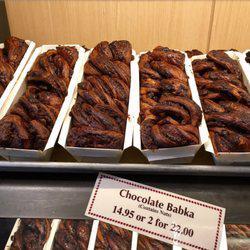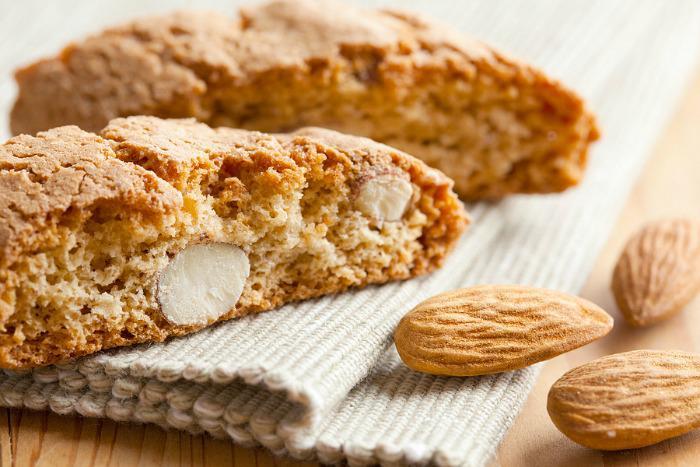The first image is the image on the left, the second image is the image on the right. Examine the images to the left and right. Is the description "Loaves of bakery items are sitting in white rectangular containers in the image on the left." accurate? Answer yes or no. Yes. The first image is the image on the left, the second image is the image on the right. Analyze the images presented: Is the assertion "An image shows multiple baked treats of the same type, packaged in open-top white rectangular boxes." valid? Answer yes or no. Yes. 